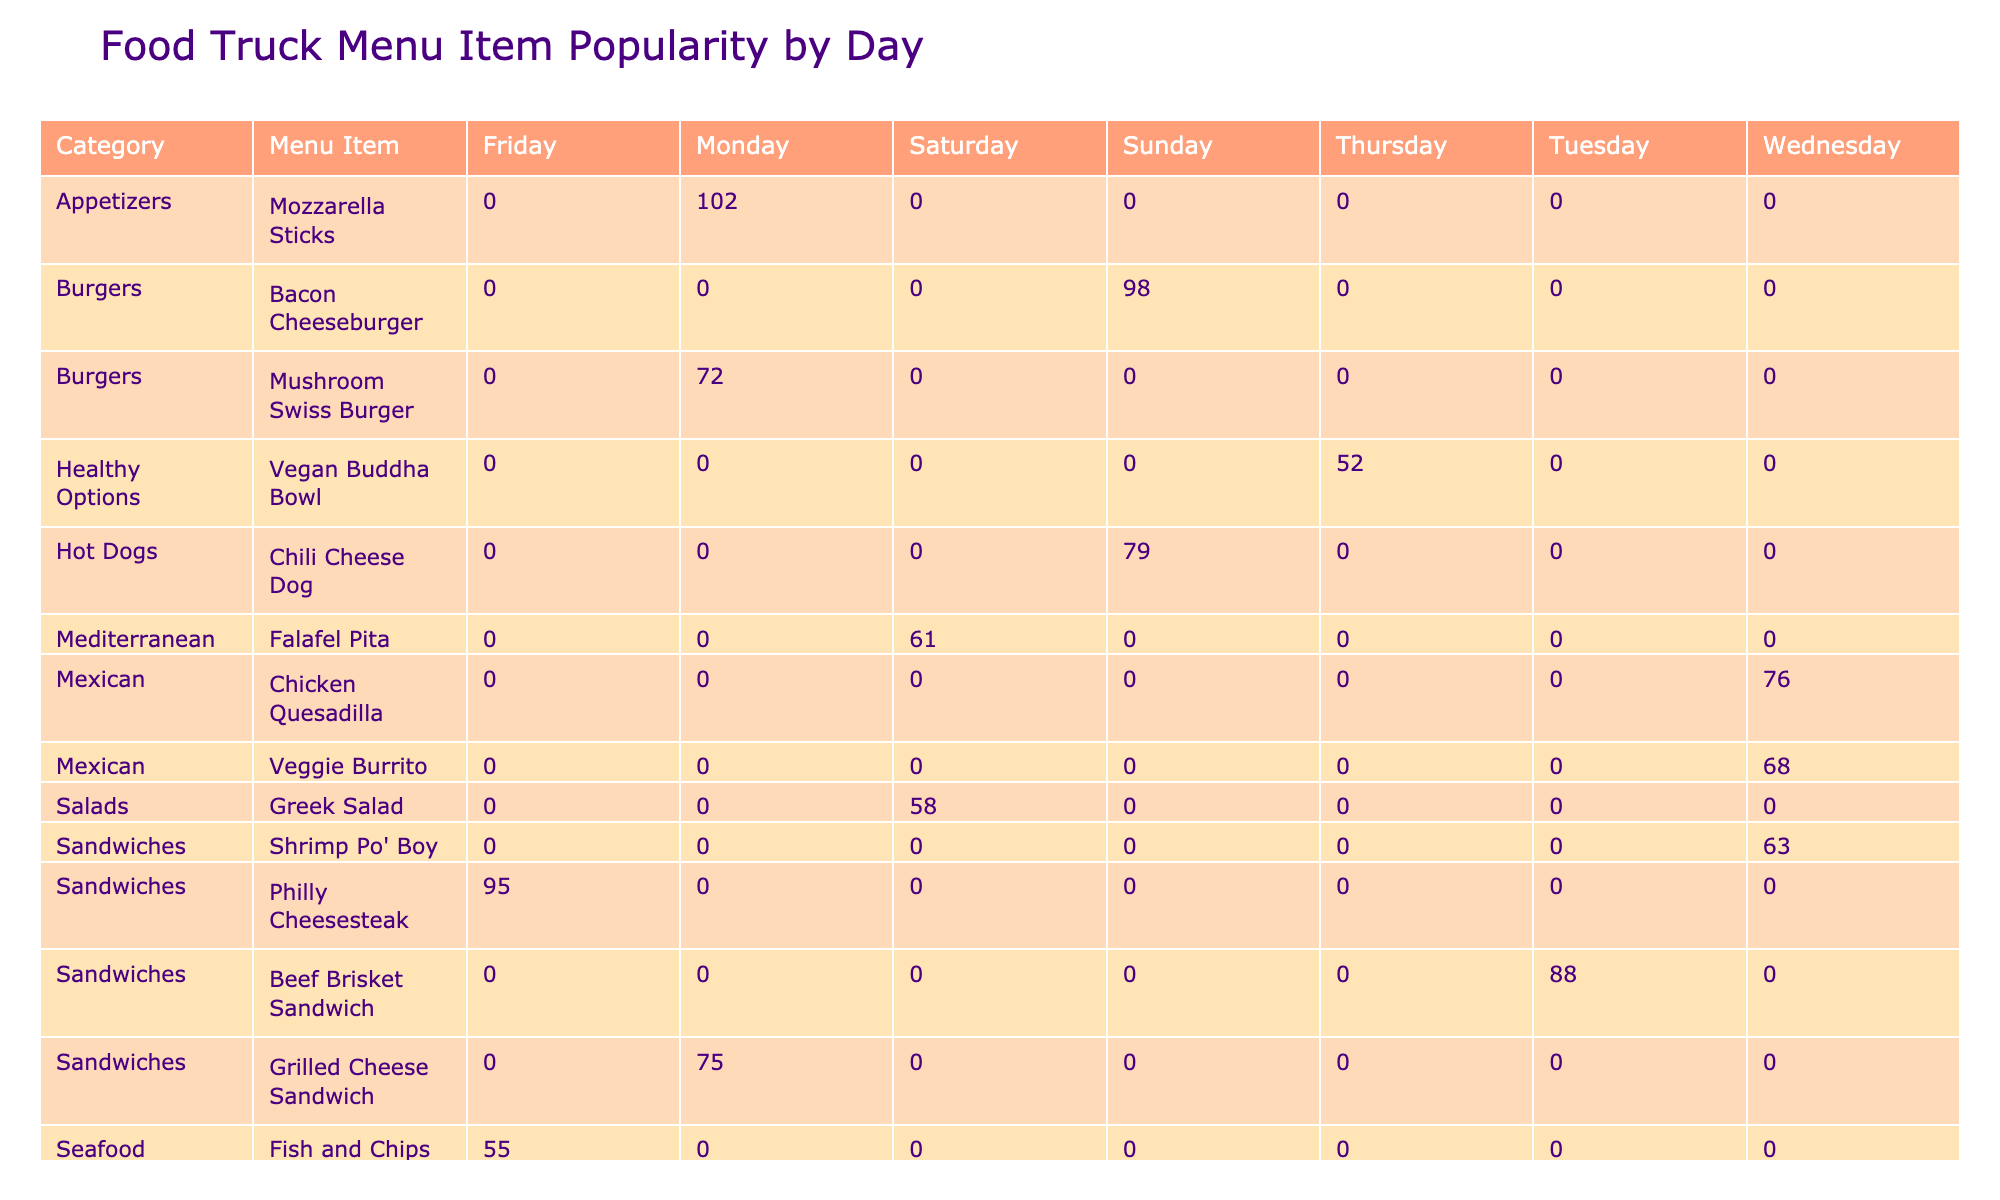What is the best-selling menu item on Thursday? The highest sales volume on Thursday can be found by looking under the Thursday column. The Loaded Fries have a sales volume of 110, which is greater than any other item on that day.
Answer: Loaded Fries Which category has the highest average rating across all menu items? To find the category with the highest average rating, we need to compute the average rating for each category. The average ratings are as follows: Sandwiches (4.5), Tacos (4.8), Mexican (4.3), Sides (4.5), Seafood (4.5), Wraps (4.4), Healthy Options (4.0), Mediterranean (4.1). The highest average is 4.8 for Tacos.
Answer: Tacos Did the Chicken Caesar Wrap sell more than the Fish and Chips? By checking the sales volumes, the Chicken Caesar Wrap sold 83 and the Fish and Chips sold 55. Since 83 is greater than 55, we can confirm that the Chicken Caesar Wrap sold more.
Answer: Yes What is the total sales volume for Burgers on all days? To get the total sales volume for the Burgers category, we sum the sales volume for both Burger items: Bacon Cheeseburger (98) and Mushroom Swiss Burger (72). The total is 98 + 72 = 170.
Answer: 170 Is the Philadelphia Cheesesteak the most popular item on Fridays? We can check the sales volume for the Philadelphia Cheesesteak on Fridays, which is 95. Comparing this to the Fish and Chips (55), it is indeed higher, making it the most popular on Fridays.
Answer: Yes Which menu item has the lowest sales volume and how much is it? The menu item with the lowest sales volume can be identified by examining the Sales Volume for each item. The Lobster Roll has a sales volume of 48, which is the lowest observed in the table.
Answer: Lobster Roll, 48 How many more sales were there for Loaded Fries compared to Sweet Potato Fries? The sales volumes show that Loaded Fries have 110 and Sweet Potato Fries have 93. The difference is 110 - 93 = 17.
Answer: 17 Which day of the week saw the highest total sales for Healthy Options? By looking for Healthy Options and their sales only on the days of the week, we find that it sold only on Thursday with a total of 52. Since that's the only day listed, it is the highest for that category.
Answer: 52 